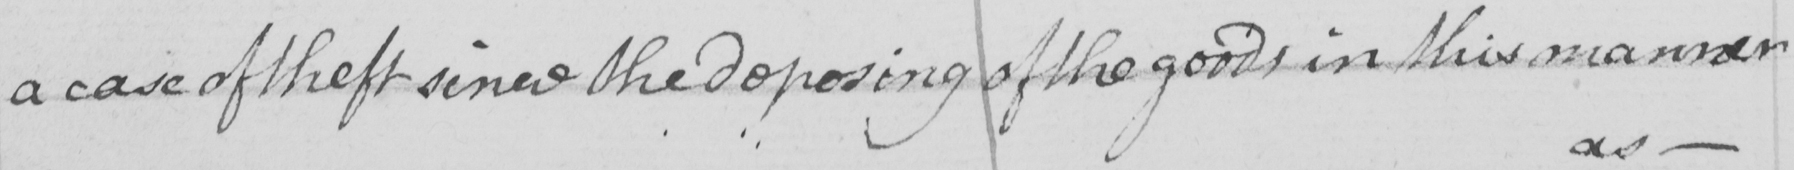Can you tell me what this handwritten text says? a case of theft since the deposing of the goods in this manner 